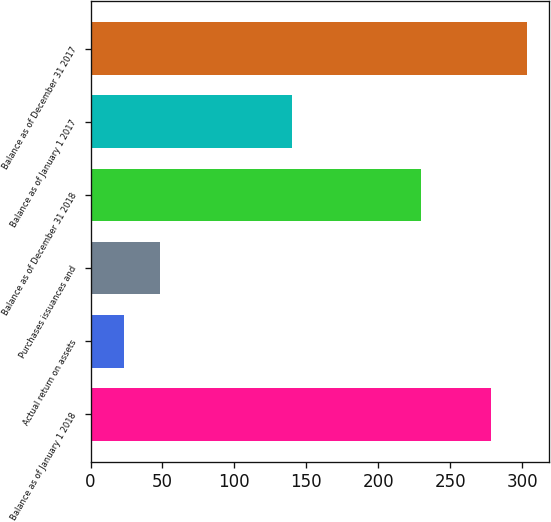<chart> <loc_0><loc_0><loc_500><loc_500><bar_chart><fcel>Balance as of January 1 2018<fcel>Actual return on assets<fcel>Purchases issuances and<fcel>Balance as of December 31 2018<fcel>Balance as of January 1 2017<fcel>Balance as of December 31 2017<nl><fcel>278<fcel>23<fcel>48.5<fcel>230<fcel>140<fcel>303.5<nl></chart> 